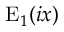Convert formula to latex. <formula><loc_0><loc_0><loc_500><loc_500>E _ { 1 } ( i x )</formula> 